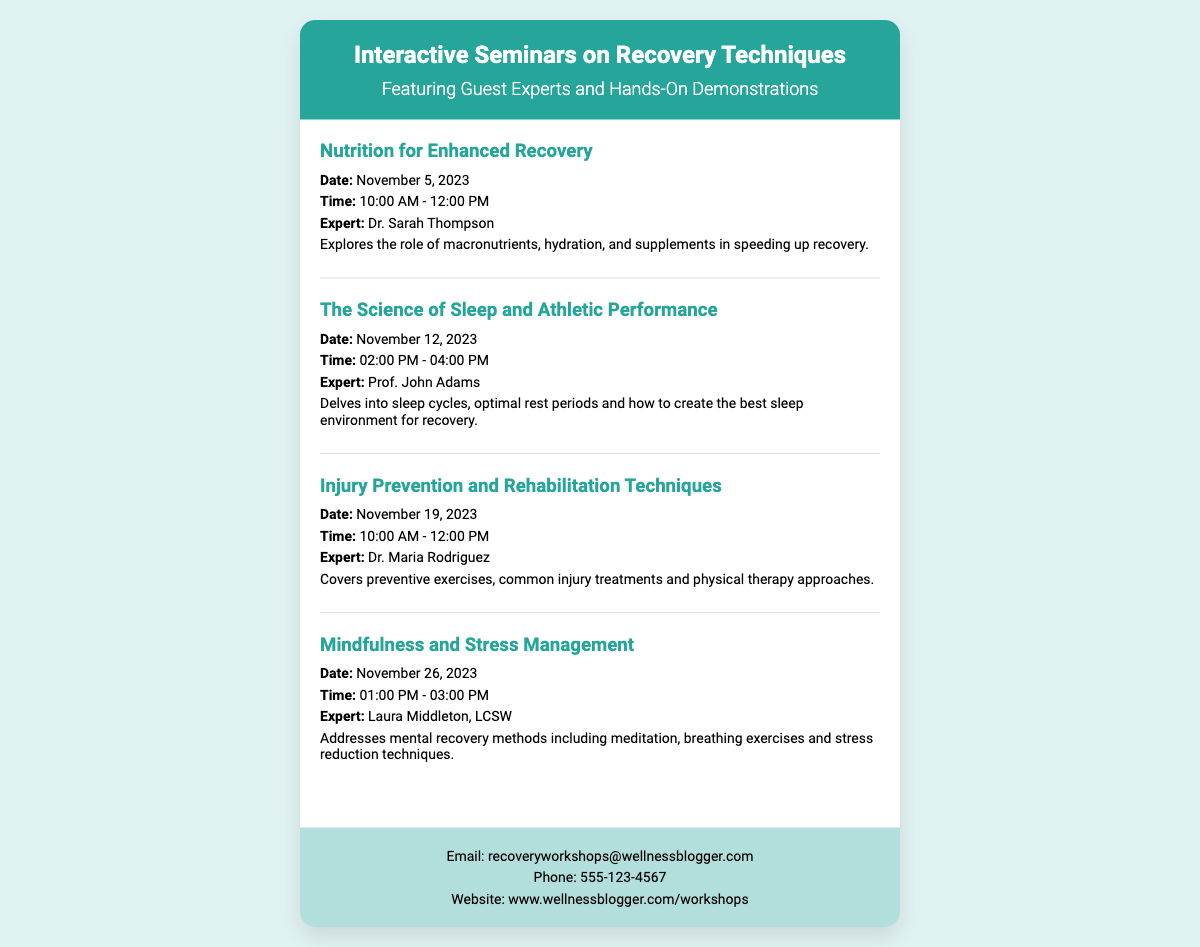What is the title of the workshop series? The title of the workshop series can be found in the card header section of the document, which is "Interactive Seminars on Recovery Techniques."
Answer: Interactive Seminars on Recovery Techniques Who is the expert for the nutrition workshop? The expert for the nutrition workshop is mentioned in the workshop details section, specifically for "Nutrition for Enhanced Recovery."
Answer: Dr. Sarah Thompson What is the date for the mindfulness workshop? The date for the mindfulness workshop is specified in the workshop details, under "Mindfulness and Stress Management."
Answer: November 26, 2023 How long does the sleep science workshop last? The duration of the sleep science workshop, "The Science of Sleep and Athletic Performance," is indicated by its start and end time in the workshop details.
Answer: 2 hours What is the main topic of the injury prevention workshop? The main topic of the injury prevention workshop can be found in the description of the "Injury Prevention and Rehabilitation Techniques" section.
Answer: Injury prevention and rehabilitation techniques What is the contact email for workshop inquiries? The contact email for workshop inquiries is listed in the contact section at the bottom of the card.
Answer: recoveryworkshops@wellnessblogger.com How many workshops are featured in the document? The total number of workshops mentioned in the document can be counted from each workshop section present in the card body.
Answer: 4 What time does the injury prevention workshop start? The start time of the injury prevention workshop can be found in the details listed under the respective workshop section.
Answer: 10:00 AM 